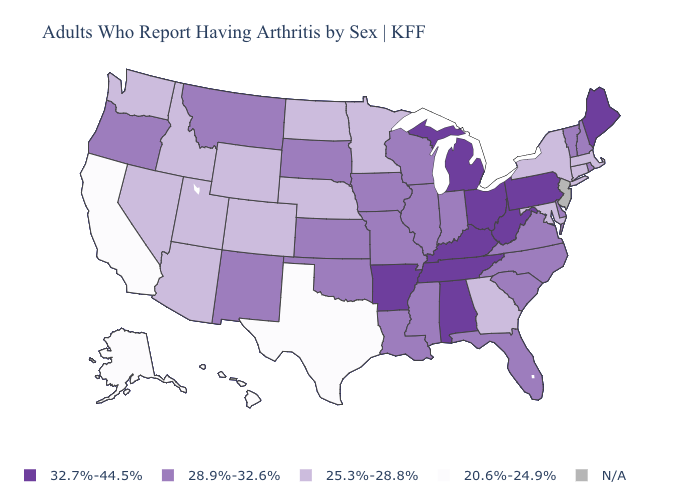What is the value of Arkansas?
Quick response, please. 32.7%-44.5%. Does the first symbol in the legend represent the smallest category?
Quick response, please. No. What is the highest value in states that border Oklahoma?
Keep it brief. 32.7%-44.5%. Among the states that border Nevada , does California have the lowest value?
Give a very brief answer. Yes. Name the states that have a value in the range 25.3%-28.8%?
Answer briefly. Arizona, Colorado, Connecticut, Georgia, Idaho, Maryland, Massachusetts, Minnesota, Nebraska, Nevada, New York, North Dakota, Utah, Washington, Wyoming. Among the states that border Minnesota , which have the lowest value?
Concise answer only. North Dakota. What is the value of South Dakota?
Quick response, please. 28.9%-32.6%. Name the states that have a value in the range N/A?
Answer briefly. New Jersey. What is the lowest value in states that border Maine?
Keep it brief. 28.9%-32.6%. What is the value of Colorado?
Quick response, please. 25.3%-28.8%. Which states hav the highest value in the West?
Quick response, please. Montana, New Mexico, Oregon. Name the states that have a value in the range 20.6%-24.9%?
Concise answer only. Alaska, California, Hawaii, Texas. Does Ohio have the lowest value in the MidWest?
Concise answer only. No. Is the legend a continuous bar?
Concise answer only. No. 